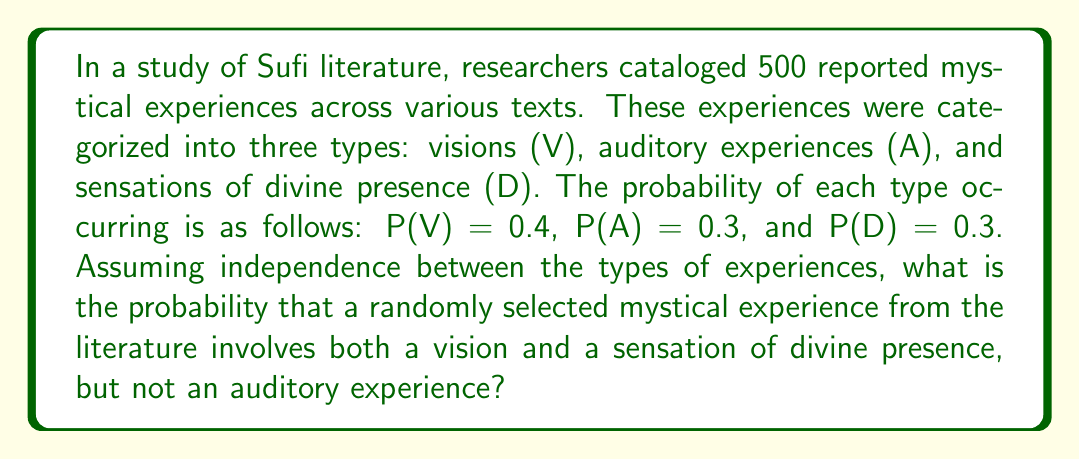Solve this math problem. To solve this problem, we'll use the principles of probability theory and the given information:

1. We have three types of mystical experiences: V (visions), A (auditory), and D (divine presence).
2. Their probabilities are: P(V) = 0.4, P(A) = 0.3, and P(D) = 0.3.
3. We assume independence between these types of experiences.

We need to find the probability of an experience that includes both V and D, but not A. This can be expressed as:

P(V ∩ D ∩ A')

Where A' represents the complement of A (not A).

Using the multiplication rule for independent events:

P(V ∩ D ∩ A') = P(V) × P(D) × P(A')

We know P(V) and P(D), but we need to calculate P(A'):

P(A') = 1 - P(A) = 1 - 0.3 = 0.7

Now we can substitute the values:

P(V ∩ D ∩ A') = 0.4 × 0.3 × 0.7

Calculating:

$$ P(V ∩ D ∩ A') = 0.4 \times 0.3 \times 0.7 = 0.084 $$

Therefore, the probability of a randomly selected mystical experience involving both a vision and a sensation of divine presence, but not an auditory experience, is 0.084 or 8.4%.
Answer: 0.084 